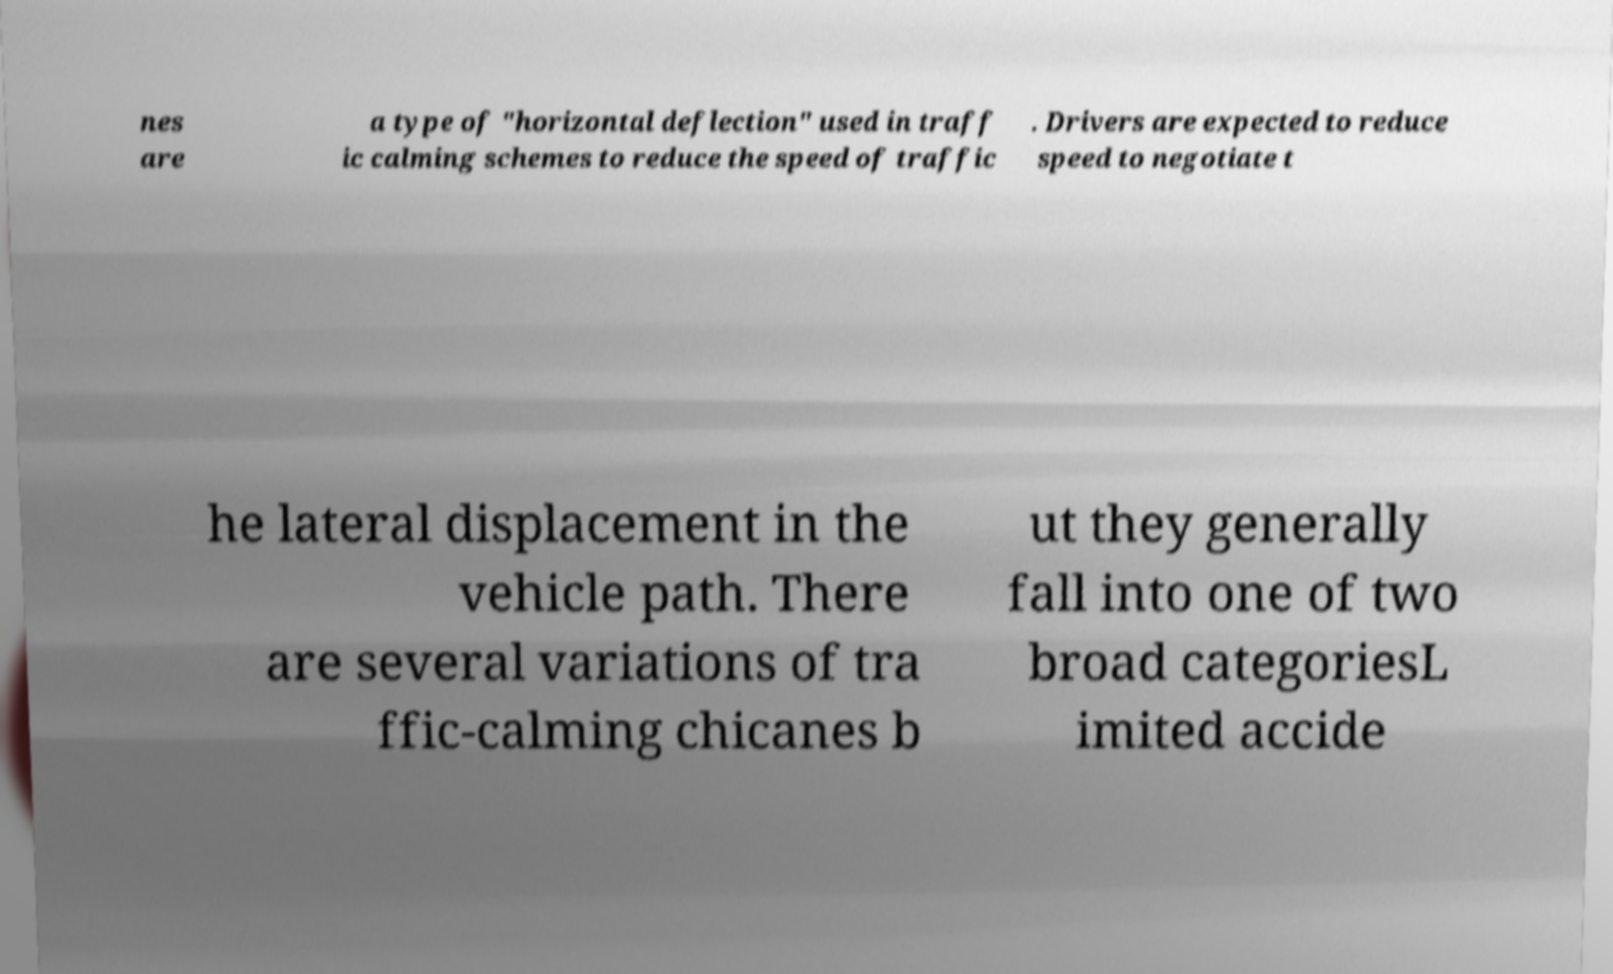Please identify and transcribe the text found in this image. nes are a type of "horizontal deflection" used in traff ic calming schemes to reduce the speed of traffic . Drivers are expected to reduce speed to negotiate t he lateral displacement in the vehicle path. There are several variations of tra ffic-calming chicanes b ut they generally fall into one of two broad categoriesL imited accide 